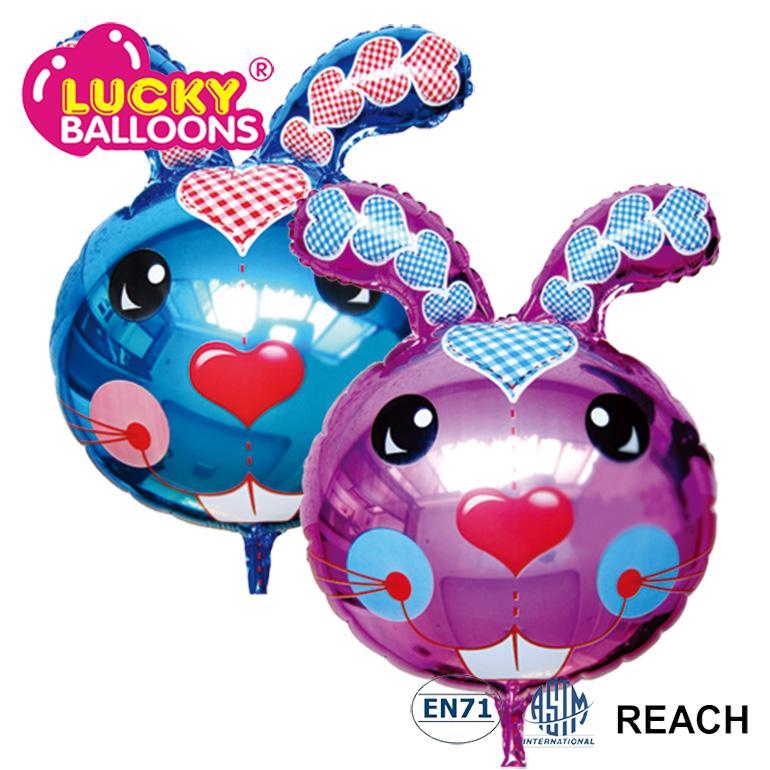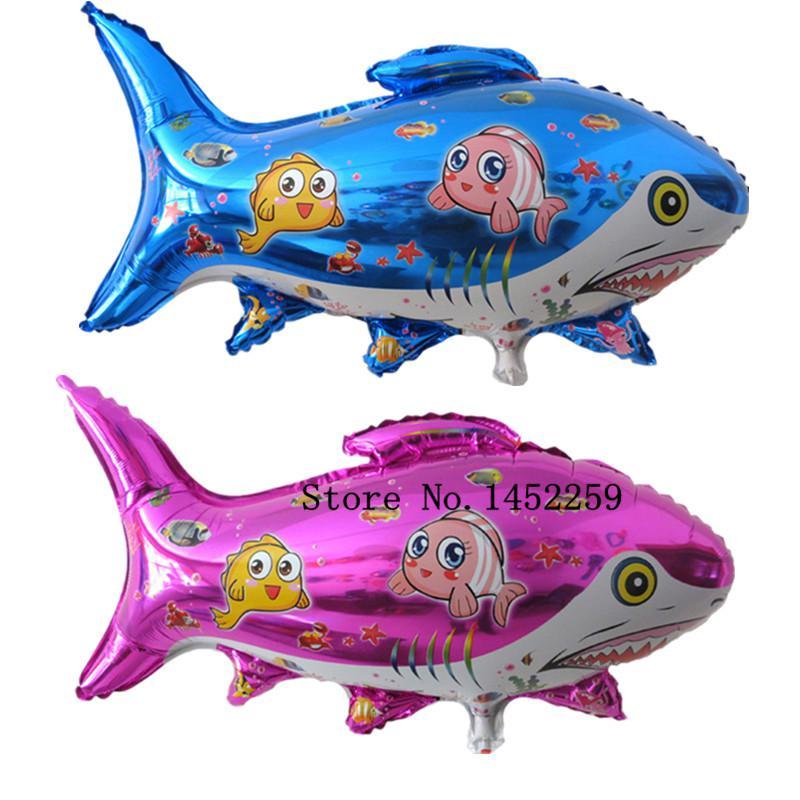The first image is the image on the left, the second image is the image on the right. Assess this claim about the two images: "There are no less than five balloons". Correct or not? Answer yes or no. No. 